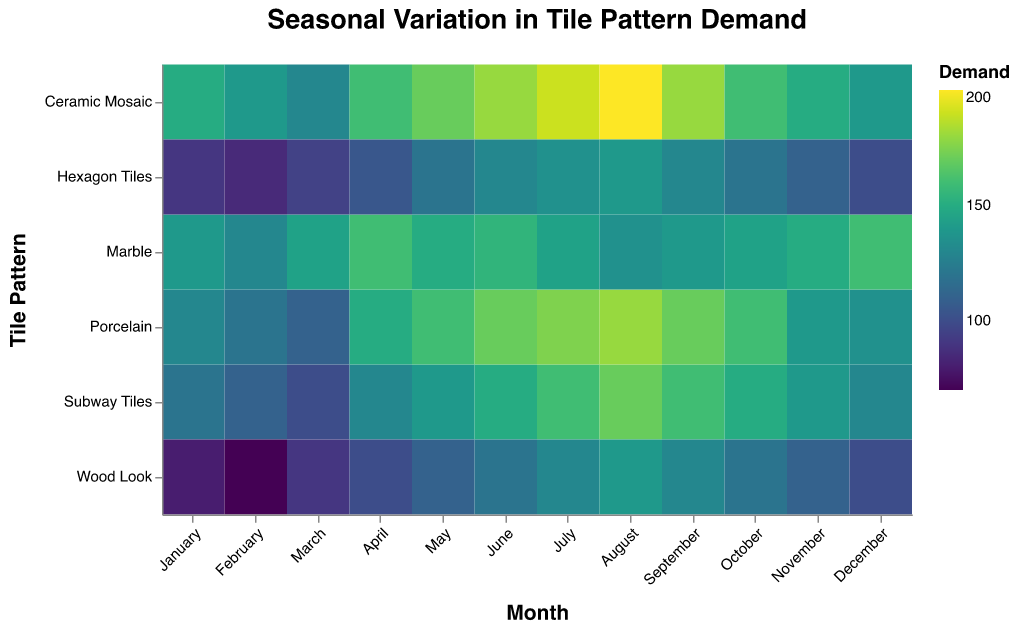What is the highest demand for Ceramic Mosaic tiles? Look for the month with the darkest color in the "Ceramic Mosaic" row, which represents the highest demand. August has the darkest cell for Ceramic Mosaic.
Answer: August Which month has the lowest demand for Wood Look tiles? Identify the lightest color in the "Wood Look" row, indicating the lowest demand. This cell corresponds to February.
Answer: February How does the demand for Marble tiles change from January to December? Track the color in the "Marble" row from January to December. It starts relatively dark in January, lightens a bit towards mid-year, and darkens again by December, reflecting an increase towards the year's end.
Answer: Increases Which tile pattern has the most consistent demand throughout the year? Look for the row that has the least variation in color intensity across all months. "Hexagon Tiles" shows the least variation in color.
Answer: Hexagon Tiles In which months does the demand for Subway Tiles exceed that for Porcelain tiles? Compare the colors in the "Subway Tiles" and "Porcelain" rows month by month. If Subway Tiles' cell is darker, demand exceeds that for Porcelain. This occurs from April to September.
Answer: April to September What is the peak demand month for Porcelain tiles? Look for the darkest cell in the "Porcelain" row, indicating the highest demand. It is August.
Answer: August Does the demand for any tile pattern remain constant during any months? Examine each row to see if any rows have multiple cells with identical color, implying constant demand. No tile pattern has a completely constant demand across months.
Answer: No What is the average demand for Hexagon Tiles in March and September? Find the demand values for Hexagon Tiles in March and September, then calculate the average: (95 + 130) / 2.
Answer: 112.5 Which tile pattern experiences the largest increase in demand between March and July? Compare the color change between March and July for each row. The "Subway Tiles" row shows the most significant darkening, indicating the largest demand increase.
Answer: Subway Tiles 